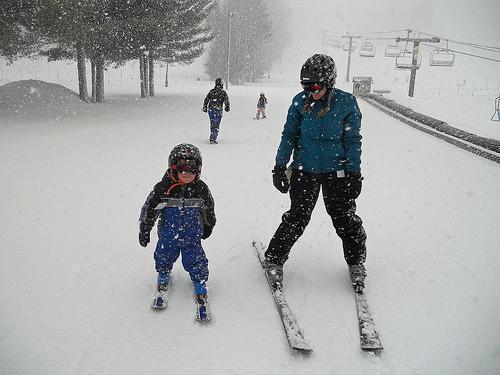How many skis are the people wearing?
Give a very brief answer. 2. 